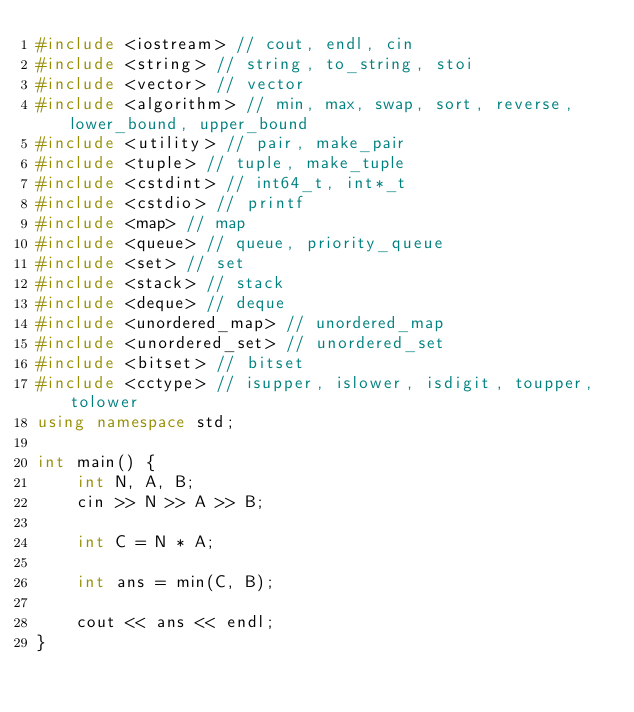<code> <loc_0><loc_0><loc_500><loc_500><_C++_>#include <iostream> // cout, endl, cin
#include <string> // string, to_string, stoi
#include <vector> // vector
#include <algorithm> // min, max, swap, sort, reverse, lower_bound, upper_bound
#include <utility> // pair, make_pair
#include <tuple> // tuple, make_tuple
#include <cstdint> // int64_t, int*_t
#include <cstdio> // printf
#include <map> // map
#include <queue> // queue, priority_queue
#include <set> // set
#include <stack> // stack
#include <deque> // deque
#include <unordered_map> // unordered_map
#include <unordered_set> // unordered_set
#include <bitset> // bitset
#include <cctype> // isupper, islower, isdigit, toupper, tolower
using namespace std;

int main() {
    int N, A, B;
    cin >> N >> A >> B;

    int C = N * A;

    int ans = min(C, B);

    cout << ans << endl;
}</code> 